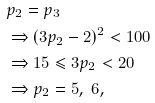Convert formula to latex. <formula><loc_0><loc_0><loc_500><loc_500>& p _ { 2 } = p _ { 3 } \\ & \Rightarrow ( 3 p _ { 2 } - 2 ) ^ { 2 } < 1 0 0 \\ & \Rightarrow 1 5 \leqslant 3 p _ { 2 } < 2 0 \\ & \Rightarrow p _ { 2 } = 5 , \ 6 ,</formula> 